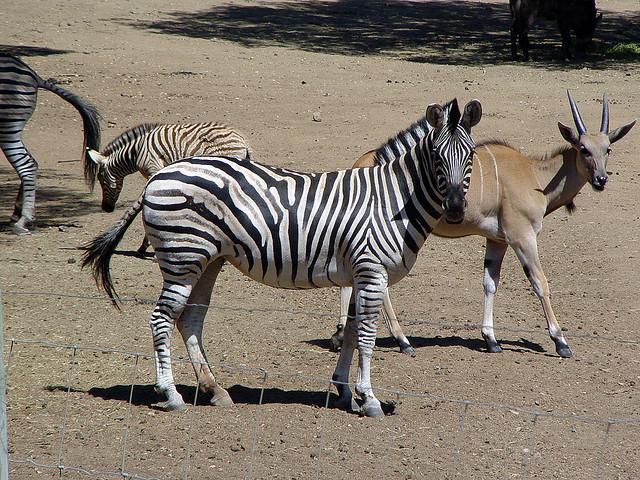How many zebras are there?
Give a very brief answer. 3. 